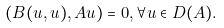<formula> <loc_0><loc_0><loc_500><loc_500>( B ( u , u ) , A u ) = 0 , \forall u \in D ( { A } ) .</formula> 